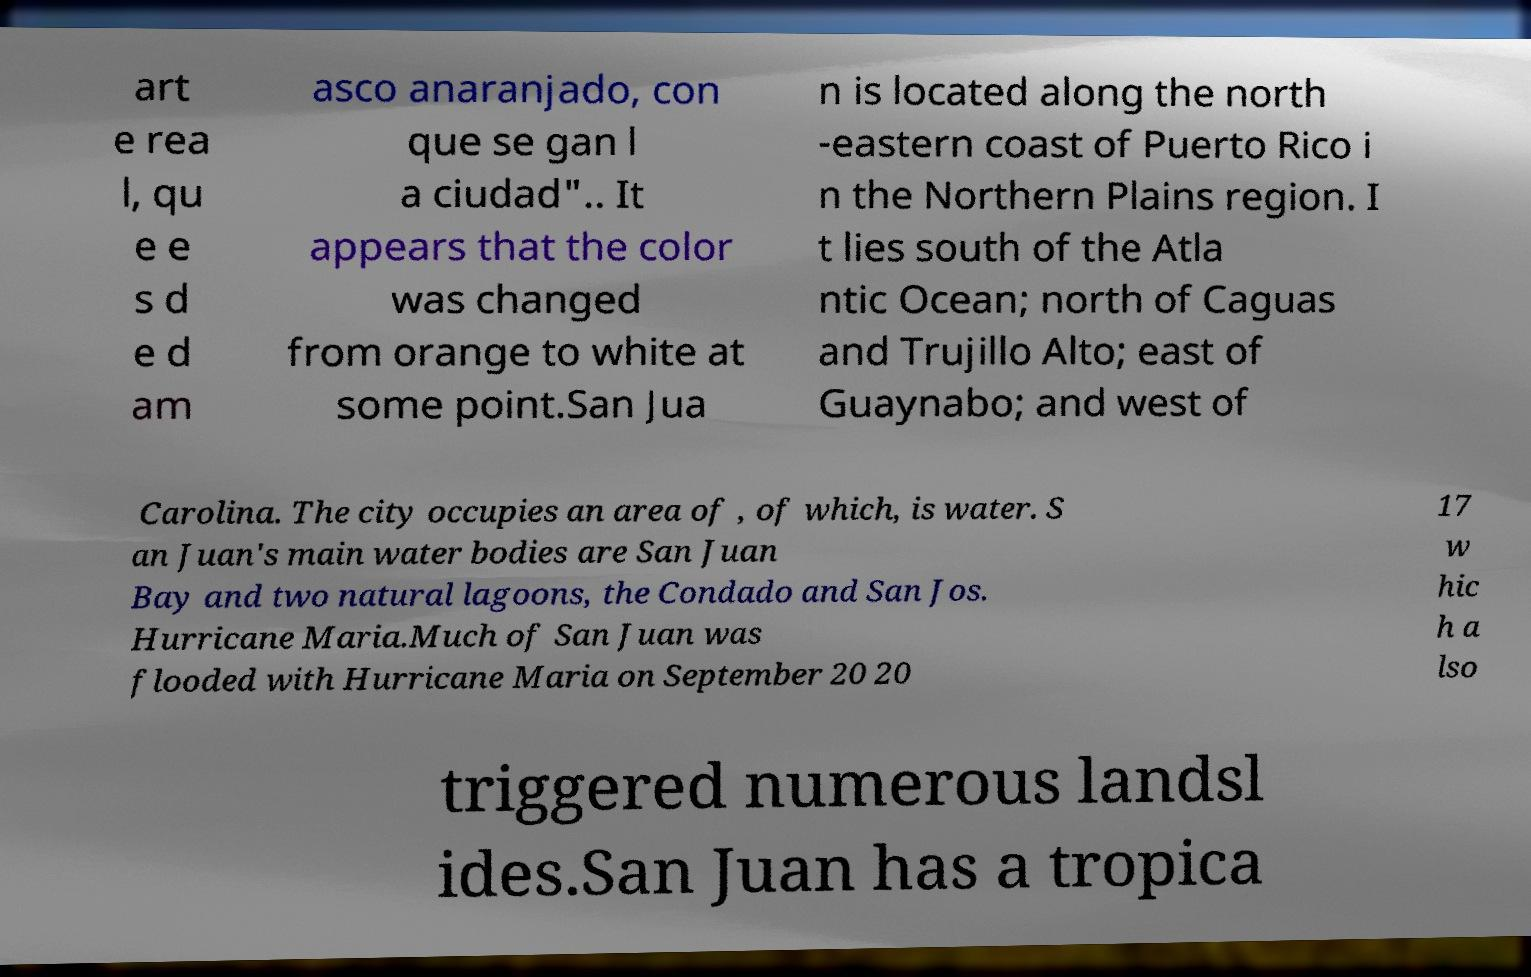What messages or text are displayed in this image? I need them in a readable, typed format. art e rea l, qu e e s d e d am asco anaranjado, con que se gan l a ciudad".. It appears that the color was changed from orange to white at some point.San Jua n is located along the north -eastern coast of Puerto Rico i n the Northern Plains region. I t lies south of the Atla ntic Ocean; north of Caguas and Trujillo Alto; east of Guaynabo; and west of Carolina. The city occupies an area of , of which, is water. S an Juan's main water bodies are San Juan Bay and two natural lagoons, the Condado and San Jos. Hurricane Maria.Much of San Juan was flooded with Hurricane Maria on September 20 20 17 w hic h a lso triggered numerous landsl ides.San Juan has a tropica 